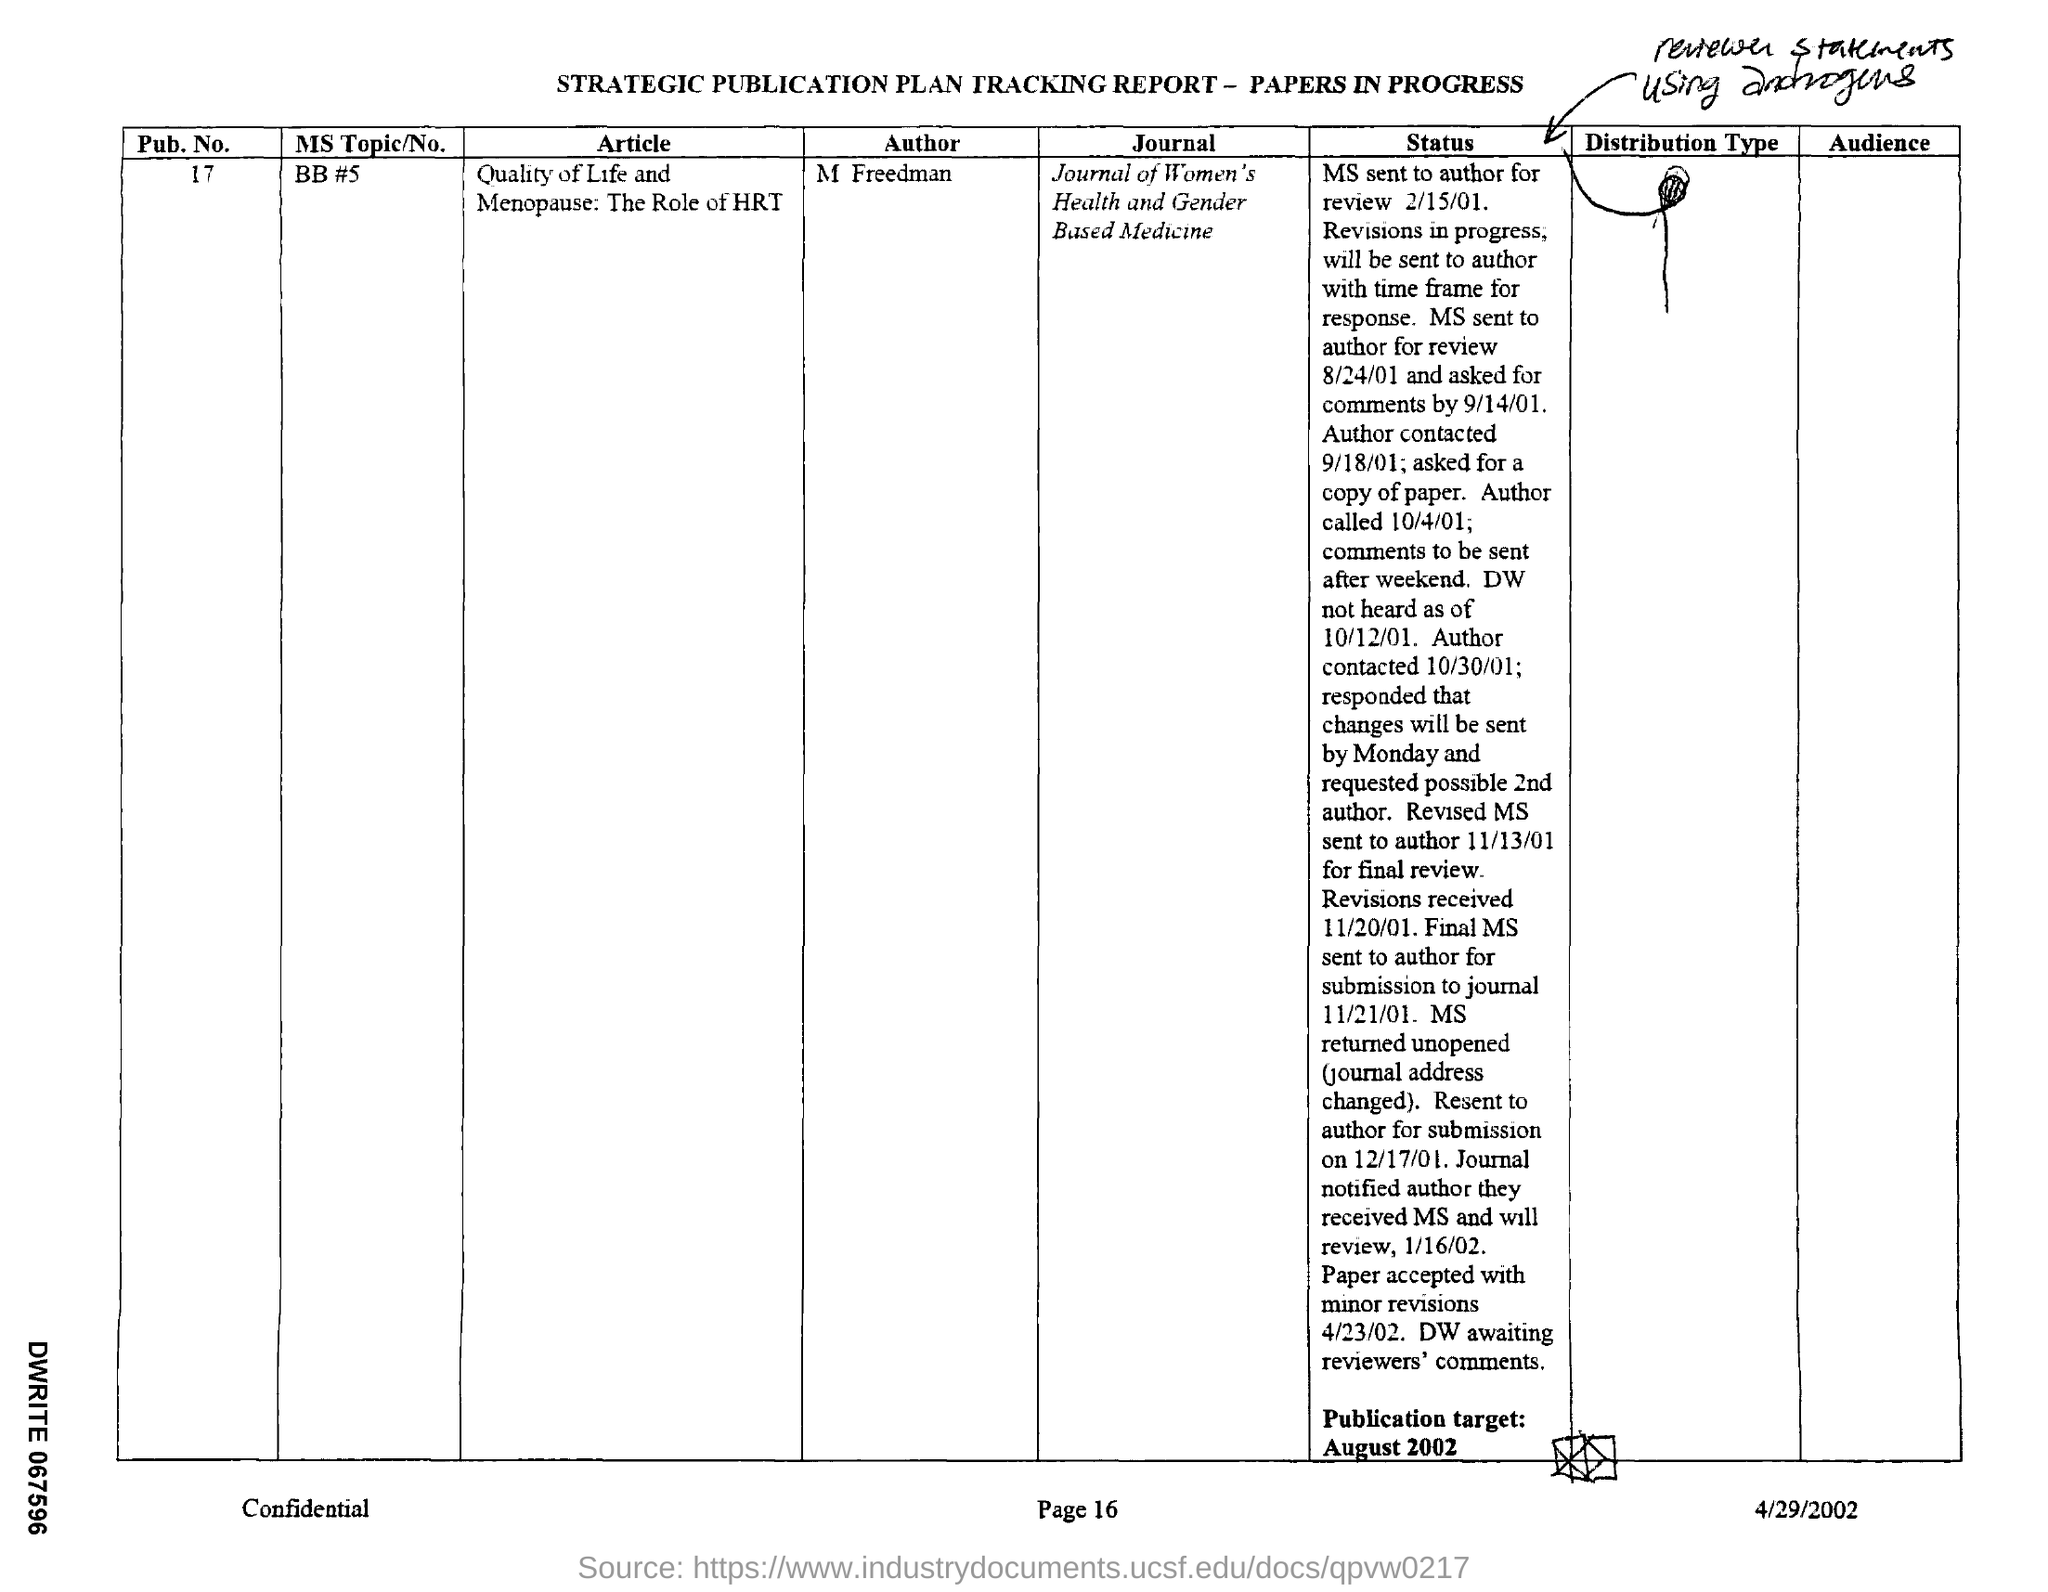What is the Pub. No.?
Make the answer very short. 17. What is the name of the article?
Ensure brevity in your answer.  Quality of Life and Menopause: The Role of HRT. Who is the author of the article?
Provide a short and direct response. M FREEDMAN. When is the Publication target?
Offer a terse response. August 2002. When is the document dated?
Ensure brevity in your answer.  4/29/2002. 